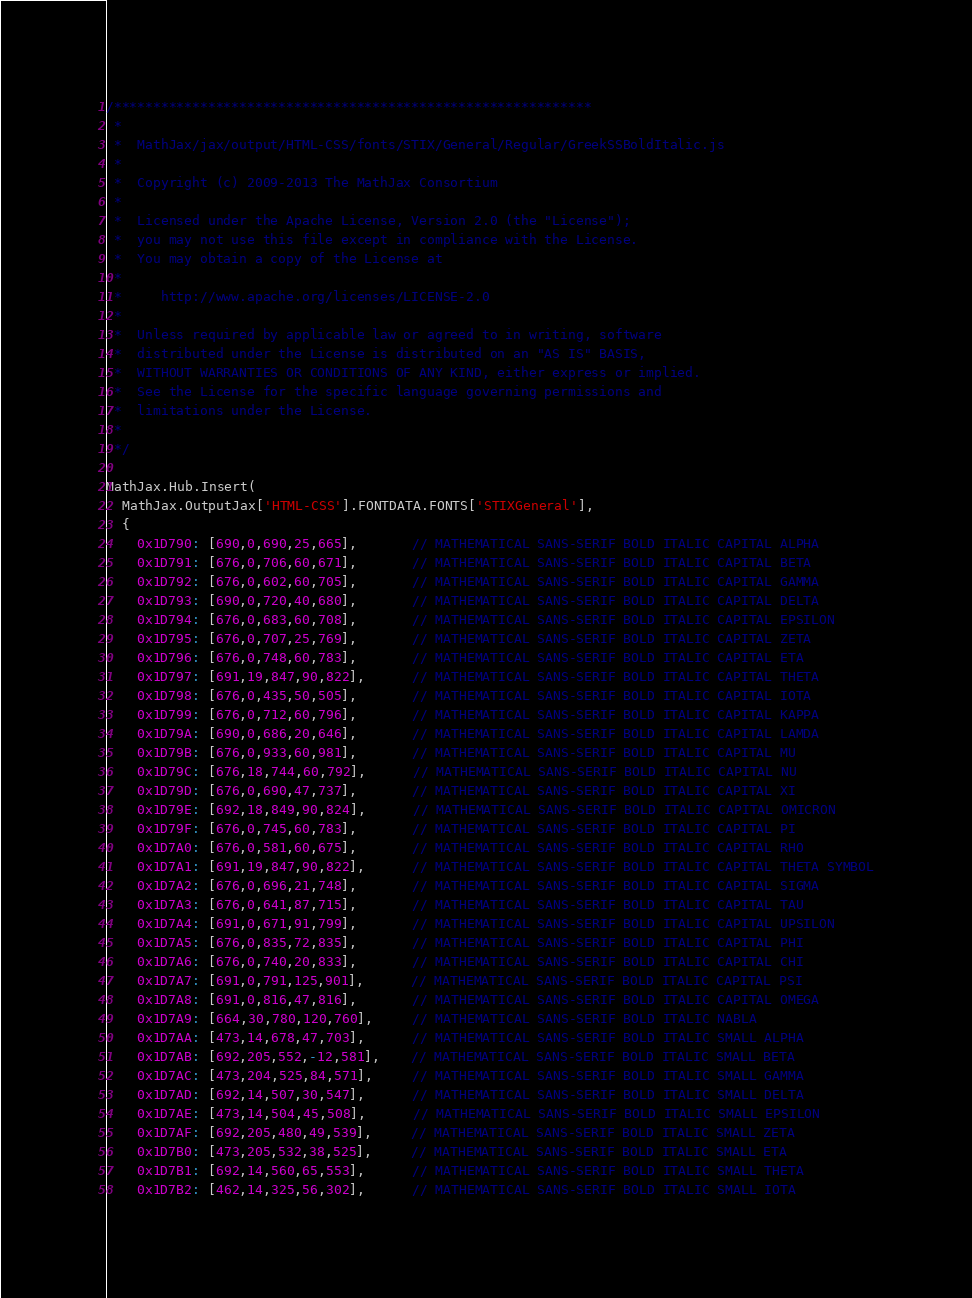Convert code to text. <code><loc_0><loc_0><loc_500><loc_500><_JavaScript_>/*************************************************************
 *
 *  MathJax/jax/output/HTML-CSS/fonts/STIX/General/Regular/GreekSSBoldItalic.js
 *
 *  Copyright (c) 2009-2013 The MathJax Consortium
 *
 *  Licensed under the Apache License, Version 2.0 (the "License");
 *  you may not use this file except in compliance with the License.
 *  You may obtain a copy of the License at
 *
 *     http://www.apache.org/licenses/LICENSE-2.0
 *
 *  Unless required by applicable law or agreed to in writing, software
 *  distributed under the License is distributed on an "AS IS" BASIS,
 *  WITHOUT WARRANTIES OR CONDITIONS OF ANY KIND, either express or implied.
 *  See the License for the specific language governing permissions and
 *  limitations under the License.
 *
 */

MathJax.Hub.Insert(
  MathJax.OutputJax['HTML-CSS'].FONTDATA.FONTS['STIXGeneral'],
  {
    0x1D790: [690,0,690,25,665],       // MATHEMATICAL SANS-SERIF BOLD ITALIC CAPITAL ALPHA
    0x1D791: [676,0,706,60,671],       // MATHEMATICAL SANS-SERIF BOLD ITALIC CAPITAL BETA
    0x1D792: [676,0,602,60,705],       // MATHEMATICAL SANS-SERIF BOLD ITALIC CAPITAL GAMMA
    0x1D793: [690,0,720,40,680],       // MATHEMATICAL SANS-SERIF BOLD ITALIC CAPITAL DELTA
    0x1D794: [676,0,683,60,708],       // MATHEMATICAL SANS-SERIF BOLD ITALIC CAPITAL EPSILON
    0x1D795: [676,0,707,25,769],       // MATHEMATICAL SANS-SERIF BOLD ITALIC CAPITAL ZETA
    0x1D796: [676,0,748,60,783],       // MATHEMATICAL SANS-SERIF BOLD ITALIC CAPITAL ETA
    0x1D797: [691,19,847,90,822],      // MATHEMATICAL SANS-SERIF BOLD ITALIC CAPITAL THETA
    0x1D798: [676,0,435,50,505],       // MATHEMATICAL SANS-SERIF BOLD ITALIC CAPITAL IOTA
    0x1D799: [676,0,712,60,796],       // MATHEMATICAL SANS-SERIF BOLD ITALIC CAPITAL KAPPA
    0x1D79A: [690,0,686,20,646],       // MATHEMATICAL SANS-SERIF BOLD ITALIC CAPITAL LAMDA
    0x1D79B: [676,0,933,60,981],       // MATHEMATICAL SANS-SERIF BOLD ITALIC CAPITAL MU
    0x1D79C: [676,18,744,60,792],      // MATHEMATICAL SANS-SERIF BOLD ITALIC CAPITAL NU
    0x1D79D: [676,0,690,47,737],       // MATHEMATICAL SANS-SERIF BOLD ITALIC CAPITAL XI
    0x1D79E: [692,18,849,90,824],      // MATHEMATICAL SANS-SERIF BOLD ITALIC CAPITAL OMICRON
    0x1D79F: [676,0,745,60,783],       // MATHEMATICAL SANS-SERIF BOLD ITALIC CAPITAL PI
    0x1D7A0: [676,0,581,60,675],       // MATHEMATICAL SANS-SERIF BOLD ITALIC CAPITAL RHO
    0x1D7A1: [691,19,847,90,822],      // MATHEMATICAL SANS-SERIF BOLD ITALIC CAPITAL THETA SYMBOL
    0x1D7A2: [676,0,696,21,748],       // MATHEMATICAL SANS-SERIF BOLD ITALIC CAPITAL SIGMA
    0x1D7A3: [676,0,641,87,715],       // MATHEMATICAL SANS-SERIF BOLD ITALIC CAPITAL TAU
    0x1D7A4: [691,0,671,91,799],       // MATHEMATICAL SANS-SERIF BOLD ITALIC CAPITAL UPSILON
    0x1D7A5: [676,0,835,72,835],       // MATHEMATICAL SANS-SERIF BOLD ITALIC CAPITAL PHI
    0x1D7A6: [676,0,740,20,833],       // MATHEMATICAL SANS-SERIF BOLD ITALIC CAPITAL CHI
    0x1D7A7: [691,0,791,125,901],      // MATHEMATICAL SANS-SERIF BOLD ITALIC CAPITAL PSI
    0x1D7A8: [691,0,816,47,816],       // MATHEMATICAL SANS-SERIF BOLD ITALIC CAPITAL OMEGA
    0x1D7A9: [664,30,780,120,760],     // MATHEMATICAL SANS-SERIF BOLD ITALIC NABLA
    0x1D7AA: [473,14,678,47,703],      // MATHEMATICAL SANS-SERIF BOLD ITALIC SMALL ALPHA
    0x1D7AB: [692,205,552,-12,581],    // MATHEMATICAL SANS-SERIF BOLD ITALIC SMALL BETA
    0x1D7AC: [473,204,525,84,571],     // MATHEMATICAL SANS-SERIF BOLD ITALIC SMALL GAMMA
    0x1D7AD: [692,14,507,30,547],      // MATHEMATICAL SANS-SERIF BOLD ITALIC SMALL DELTA
    0x1D7AE: [473,14,504,45,508],      // MATHEMATICAL SANS-SERIF BOLD ITALIC SMALL EPSILON
    0x1D7AF: [692,205,480,49,539],     // MATHEMATICAL SANS-SERIF BOLD ITALIC SMALL ZETA
    0x1D7B0: [473,205,532,38,525],     // MATHEMATICAL SANS-SERIF BOLD ITALIC SMALL ETA
    0x1D7B1: [692,14,560,65,553],      // MATHEMATICAL SANS-SERIF BOLD ITALIC SMALL THETA
    0x1D7B2: [462,14,325,56,302],      // MATHEMATICAL SANS-SERIF BOLD ITALIC SMALL IOTA</code> 